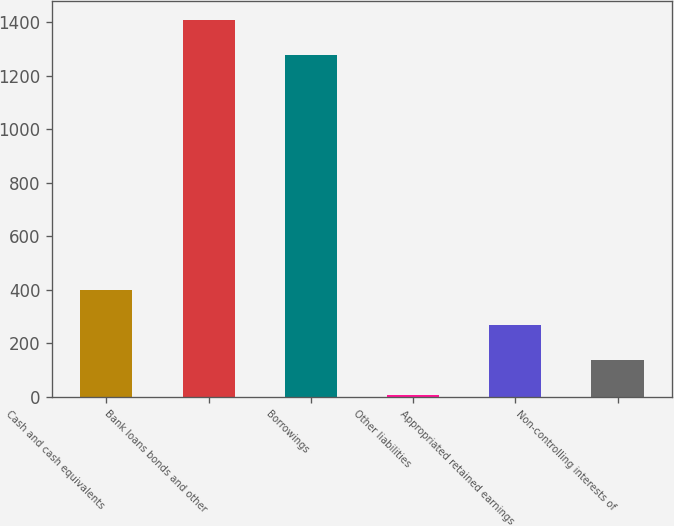Convert chart. <chart><loc_0><loc_0><loc_500><loc_500><bar_chart><fcel>Cash and cash equivalents<fcel>Bank loans bonds and other<fcel>Borrowings<fcel>Other liabilities<fcel>Appropriated retained earnings<fcel>Non-controlling interests of<nl><fcel>398.5<fcel>1408.5<fcel>1278<fcel>7<fcel>268<fcel>137.5<nl></chart> 